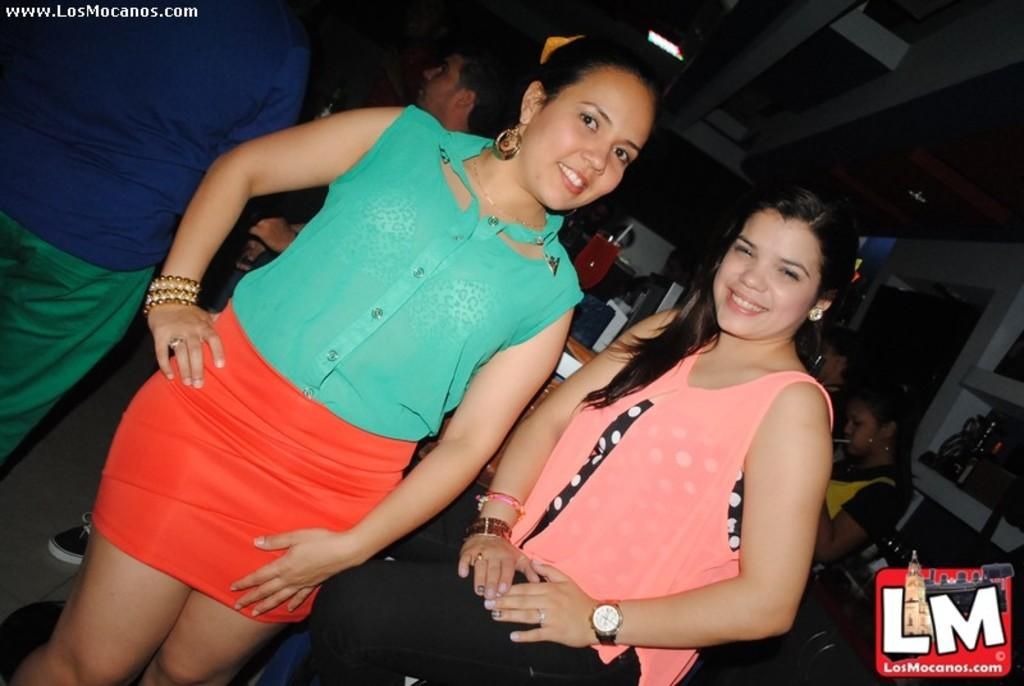How many women are in the image? There are two women in the image. What is the facial expression of the women? The women are smiling. What can be seen in the background of the image? There is a glass with a drink and people visible in the background of the image. What is used to drink the beverage in the glass? There is a straw in the glass. What effect does the car have on the recess in the image? There is no car present in the image, so it cannot have any effect on the recess. 